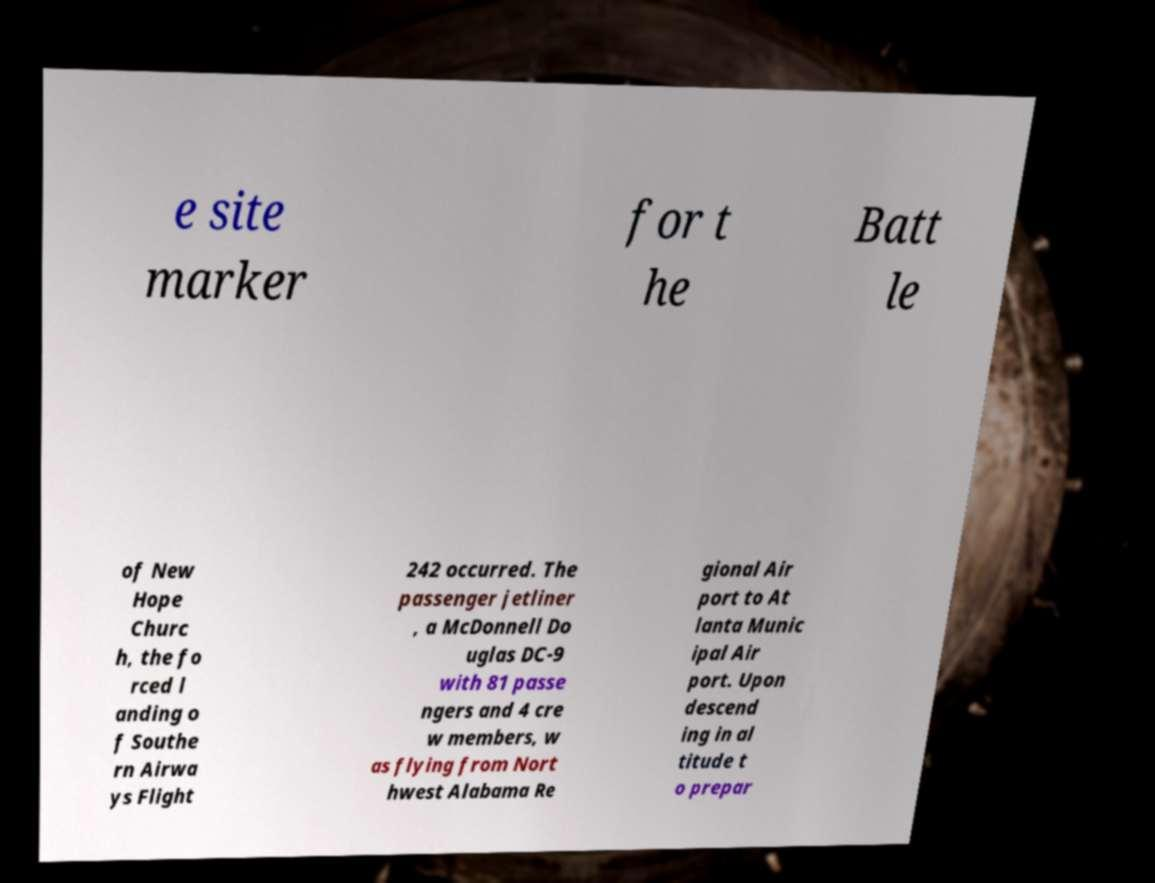Could you extract and type out the text from this image? e site marker for t he Batt le of New Hope Churc h, the fo rced l anding o f Southe rn Airwa ys Flight 242 occurred. The passenger jetliner , a McDonnell Do uglas DC-9 with 81 passe ngers and 4 cre w members, w as flying from Nort hwest Alabama Re gional Air port to At lanta Munic ipal Air port. Upon descend ing in al titude t o prepar 